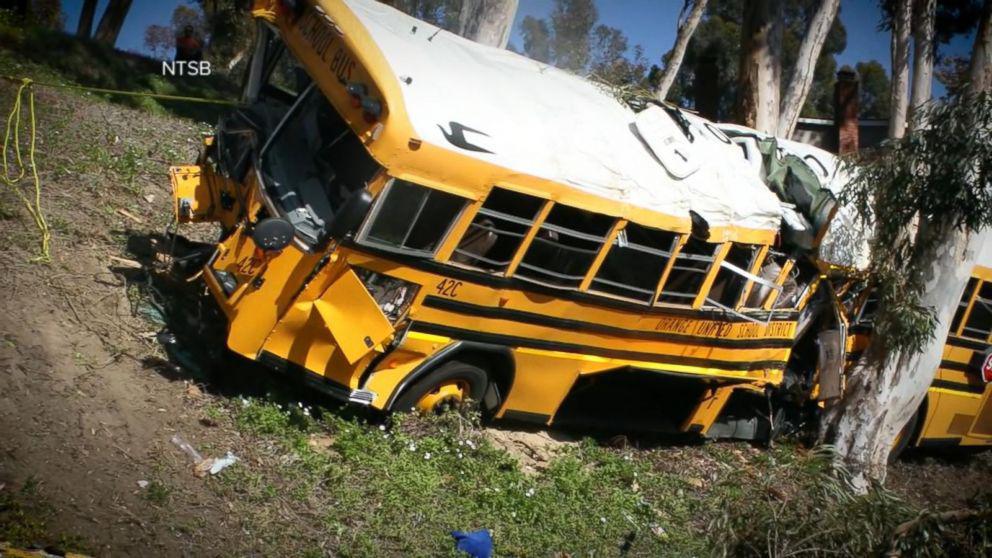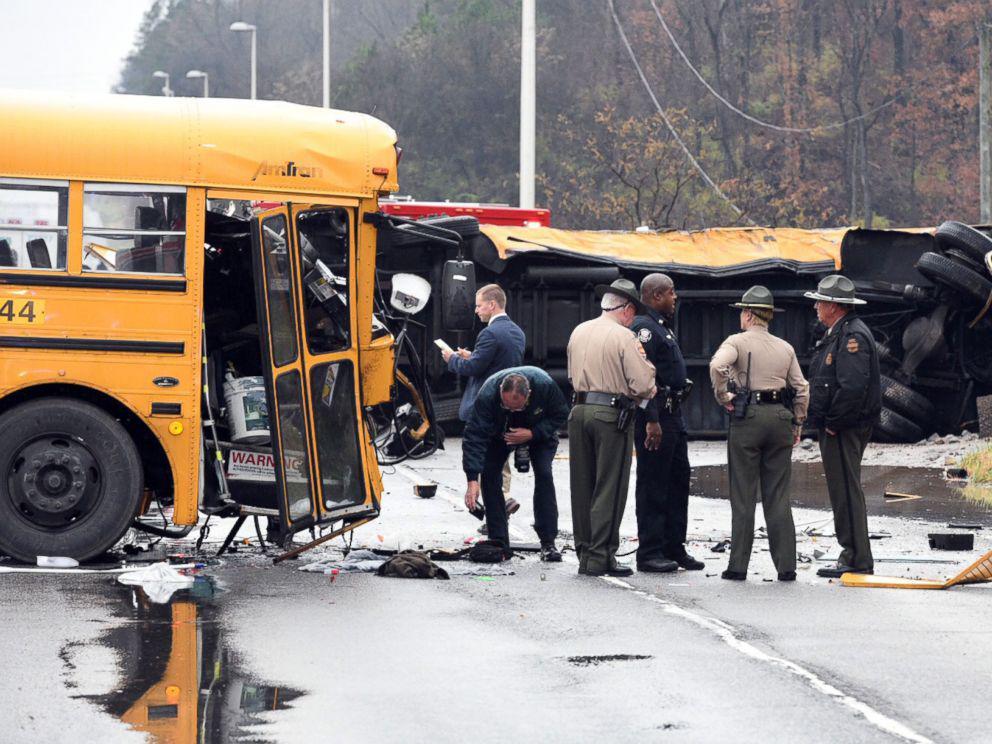The first image is the image on the left, the second image is the image on the right. Analyze the images presented: Is the assertion "A blue tarp covers the side of the bus in one of the images." valid? Answer yes or no. No. The first image is the image on the left, the second image is the image on the right. Examine the images to the left and right. Is the description "there is a bus on the back of a flat bed tow truck" accurate? Answer yes or no. No. 